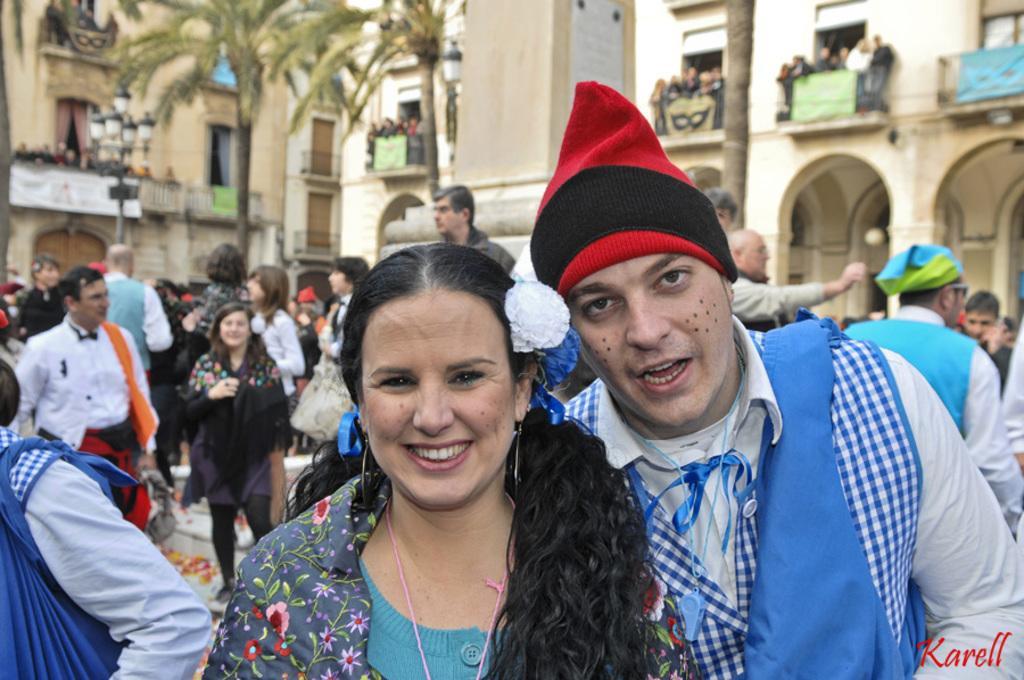Could you give a brief overview of what you see in this image? This image is clicked outside. There are many people in this image. In the front, the man is wearing red cap. In the background, there is a building along with the trees. At the bottom, there is ground. 